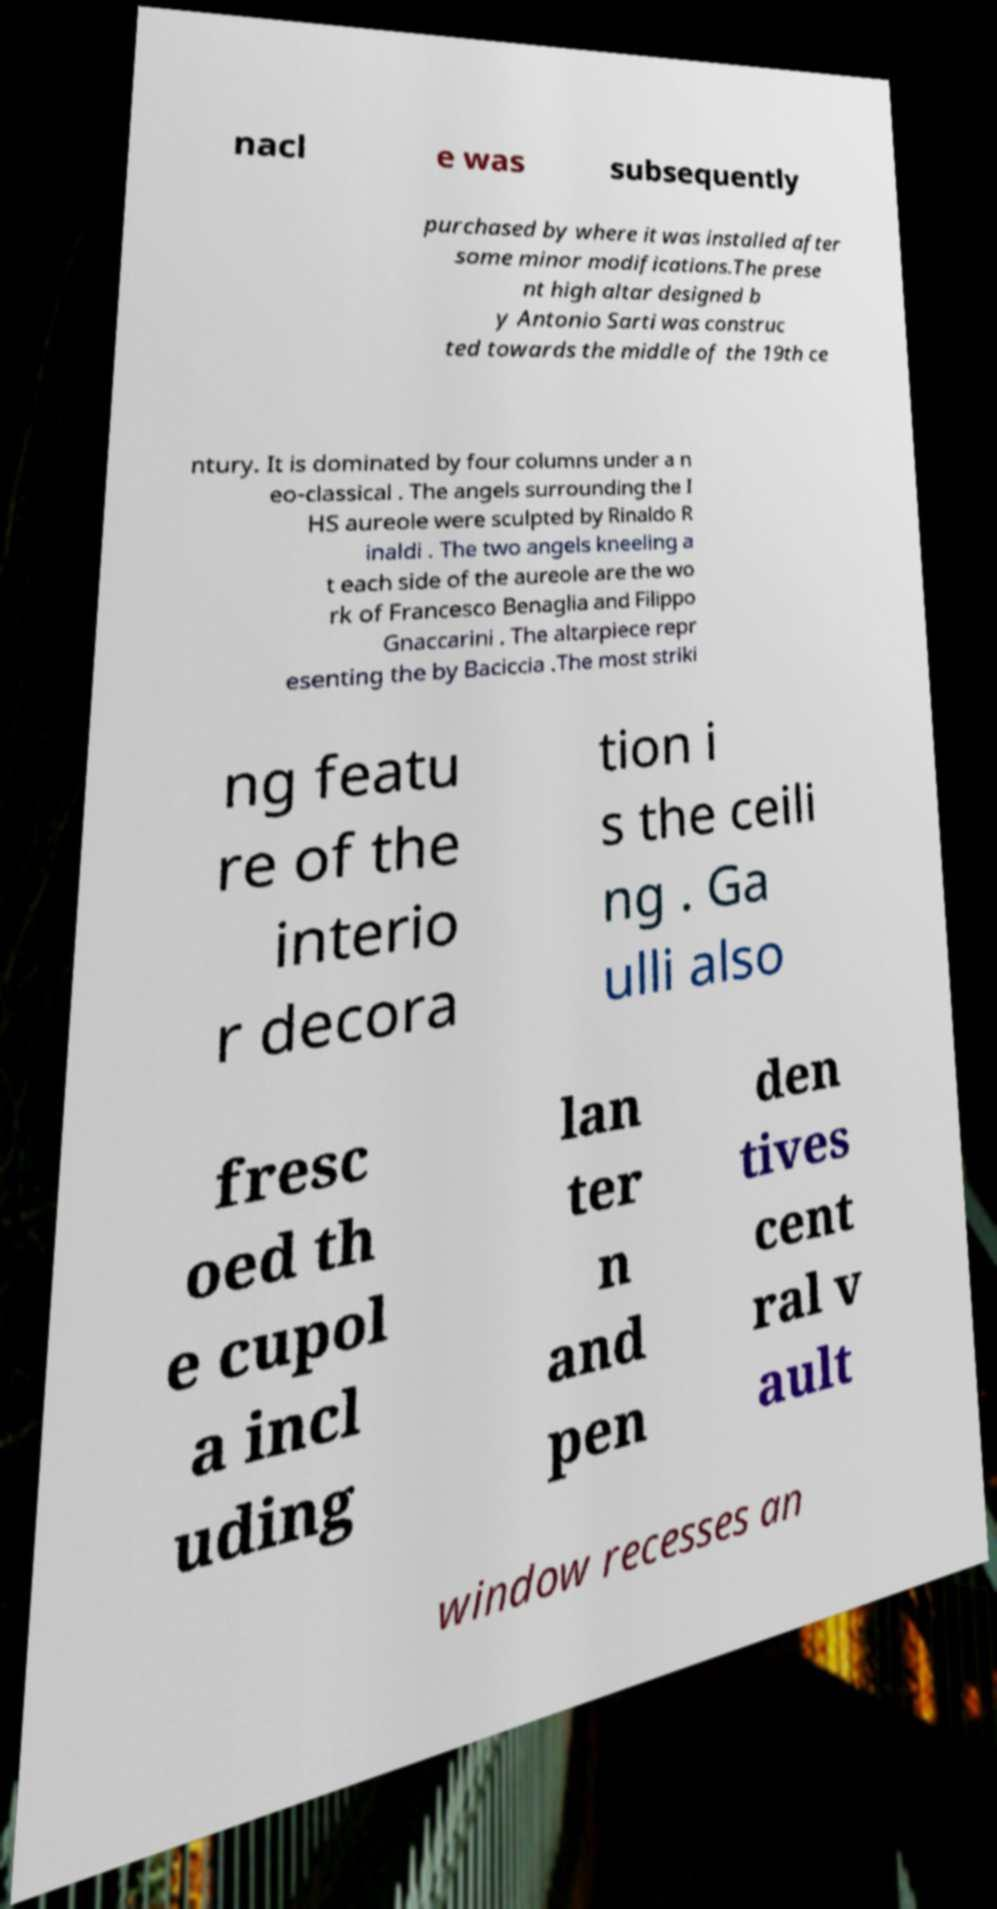Please read and relay the text visible in this image. What does it say? nacl e was subsequently purchased by where it was installed after some minor modifications.The prese nt high altar designed b y Antonio Sarti was construc ted towards the middle of the 19th ce ntury. It is dominated by four columns under a n eo-classical . The angels surrounding the I HS aureole were sculpted by Rinaldo R inaldi . The two angels kneeling a t each side of the aureole are the wo rk of Francesco Benaglia and Filippo Gnaccarini . The altarpiece repr esenting the by Baciccia .The most striki ng featu re of the interio r decora tion i s the ceili ng . Ga ulli also fresc oed th e cupol a incl uding lan ter n and pen den tives cent ral v ault window recesses an 